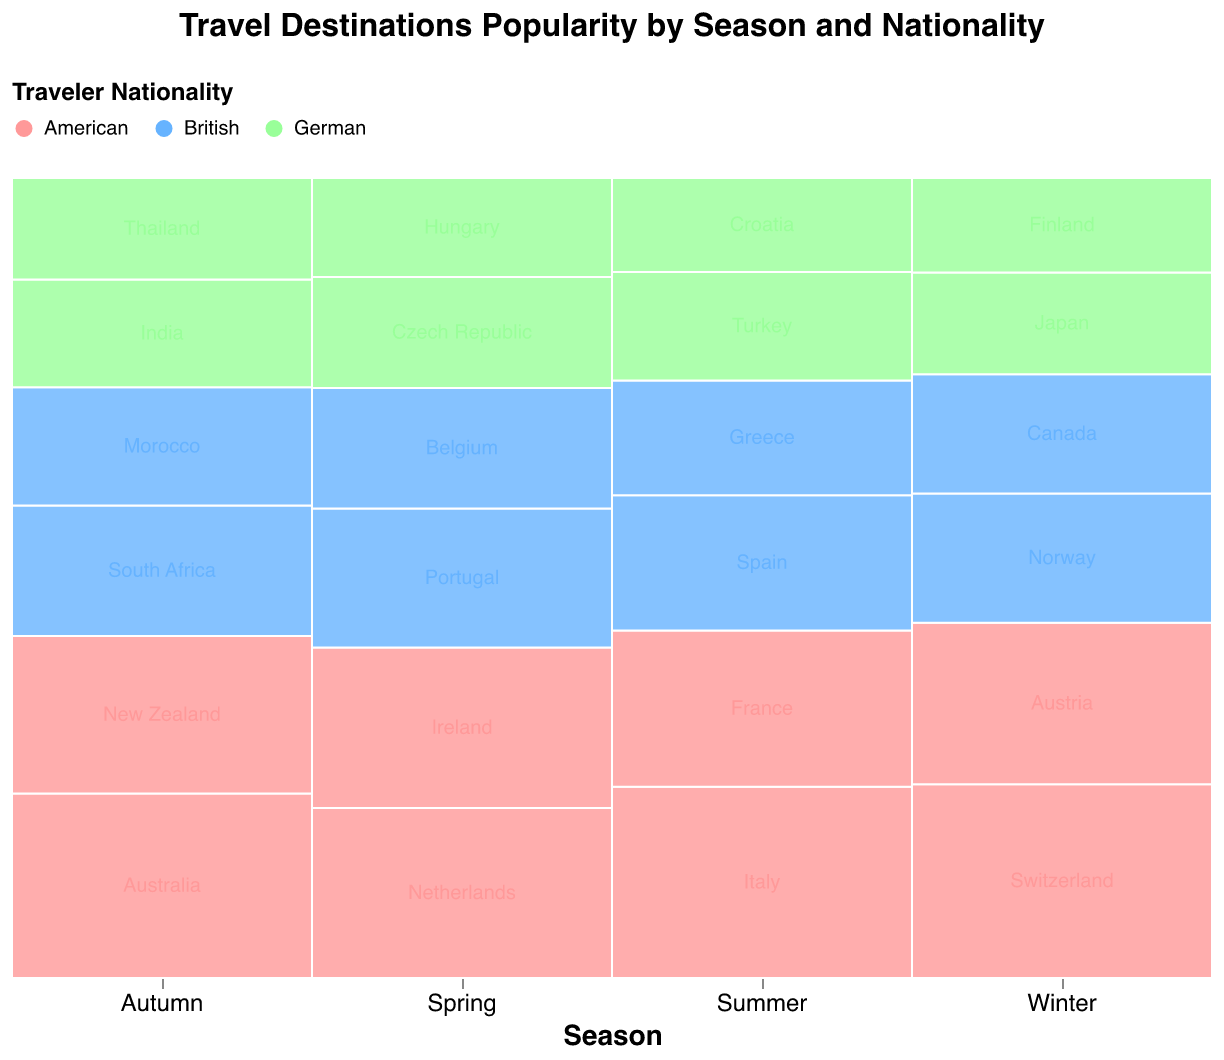Which nationality travels the most in summer? Americans are the most popular travelers in summer, as the plot shows the highest count for American travelers visiting Italy and France in that season.
Answer: Americans Which season has the least travelers overall? Winter has the least travelers overall, indicated by the smaller cumulative height of the stacked bars in the mosaic plot compared to other seasons.
Answer: Winter How does the popularity of Germany as a destination among Americans change with seasons? Germany is not listed as a destination for Americans in any of the seasons shown in the plot, indicating it is not a popular destination among Americans.
Answer: Not popular Arrange the nationalities in order of their popularity for traveling in summer from highest to lowest. By observing the heights of the stacked bars for each nationality in summer, Americans have the highest segment, followed by British, and Germans are the least.
Answer: Americans, British, Germans How many destinations do Germans prefer to visit in winter? There are two destinations preferred by Germans in winter, as indicated by the unique segments for Germany containing Japan and Finland.
Answer: 2 Compare the number of British travelers to South Africa in autumn with American travelers to New Zealand in the same season. The American travelers to New Zealand have a smaller segment size compared to the British travelers to South Africa, indicating fewer American travelers.
Answer: British travelers to South Africa are more Is Italy a popular destination for British travelers? The plot does not show Italy as a destination for British travelers, indicating it is not a popular choice for them.
Answer: No Which destinations do Americans prefer in the spring and autumn seasons? In spring, Americans prefer the Netherlands and Ireland. In autumn, they prefer Australia and New Zealand, as indicated by the segments labeled for these destinations.
Answer: Netherlands, Ireland (Spring); Australia, New Zealand (Autumn) 